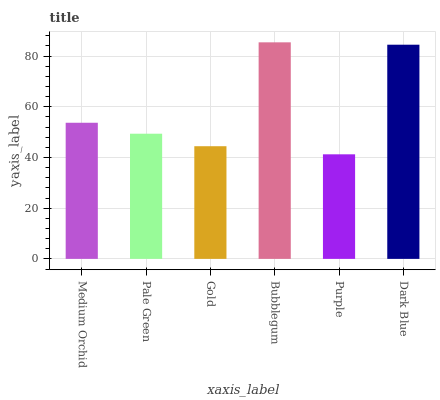Is Purple the minimum?
Answer yes or no. Yes. Is Bubblegum the maximum?
Answer yes or no. Yes. Is Pale Green the minimum?
Answer yes or no. No. Is Pale Green the maximum?
Answer yes or no. No. Is Medium Orchid greater than Pale Green?
Answer yes or no. Yes. Is Pale Green less than Medium Orchid?
Answer yes or no. Yes. Is Pale Green greater than Medium Orchid?
Answer yes or no. No. Is Medium Orchid less than Pale Green?
Answer yes or no. No. Is Medium Orchid the high median?
Answer yes or no. Yes. Is Pale Green the low median?
Answer yes or no. Yes. Is Bubblegum the high median?
Answer yes or no. No. Is Gold the low median?
Answer yes or no. No. 